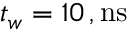Convert formula to latex. <formula><loc_0><loc_0><loc_500><loc_500>t _ { w } = 1 0 \, , n s</formula> 